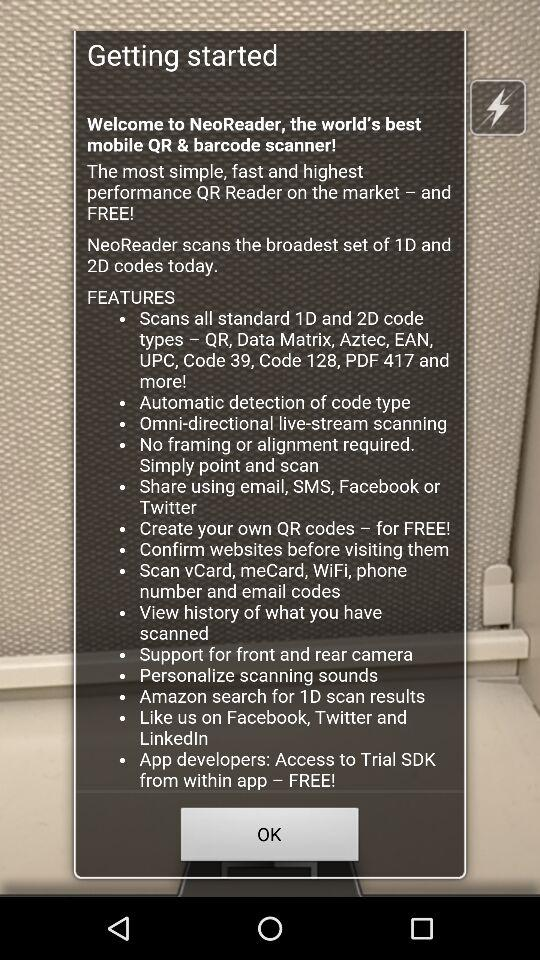Can we create our own QR code?
When the provided information is insufficient, respond with <no answer>. <no answer> 